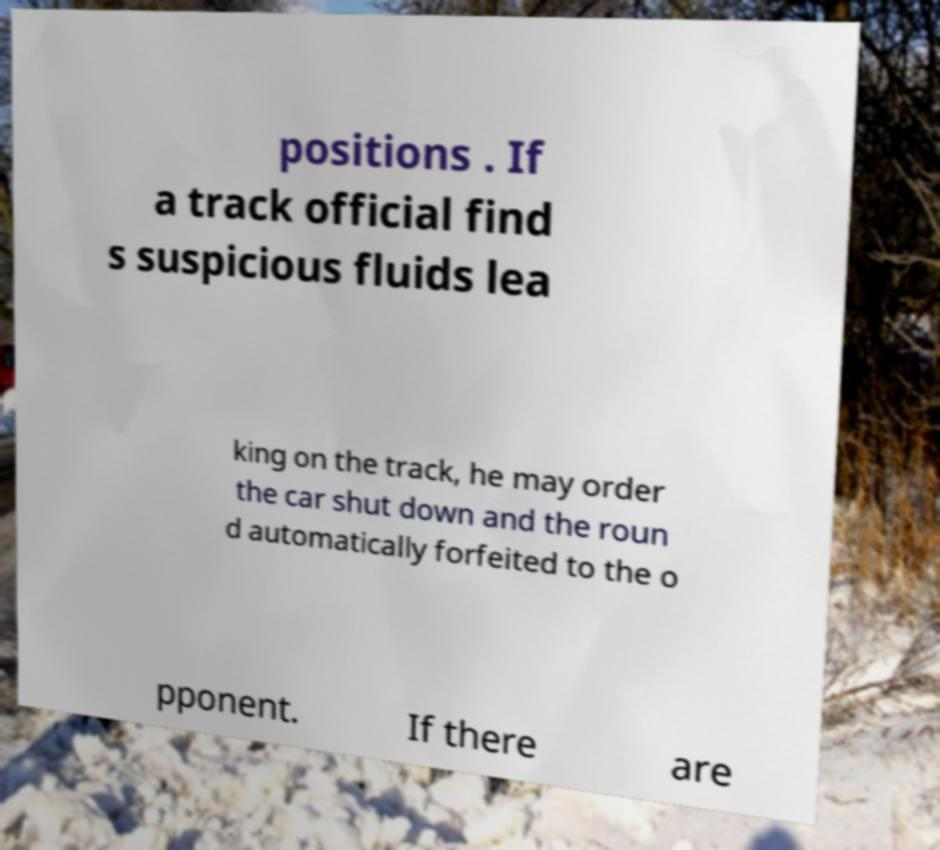I need the written content from this picture converted into text. Can you do that? positions . If a track official find s suspicious fluids lea king on the track, he may order the car shut down and the roun d automatically forfeited to the o pponent. If there are 